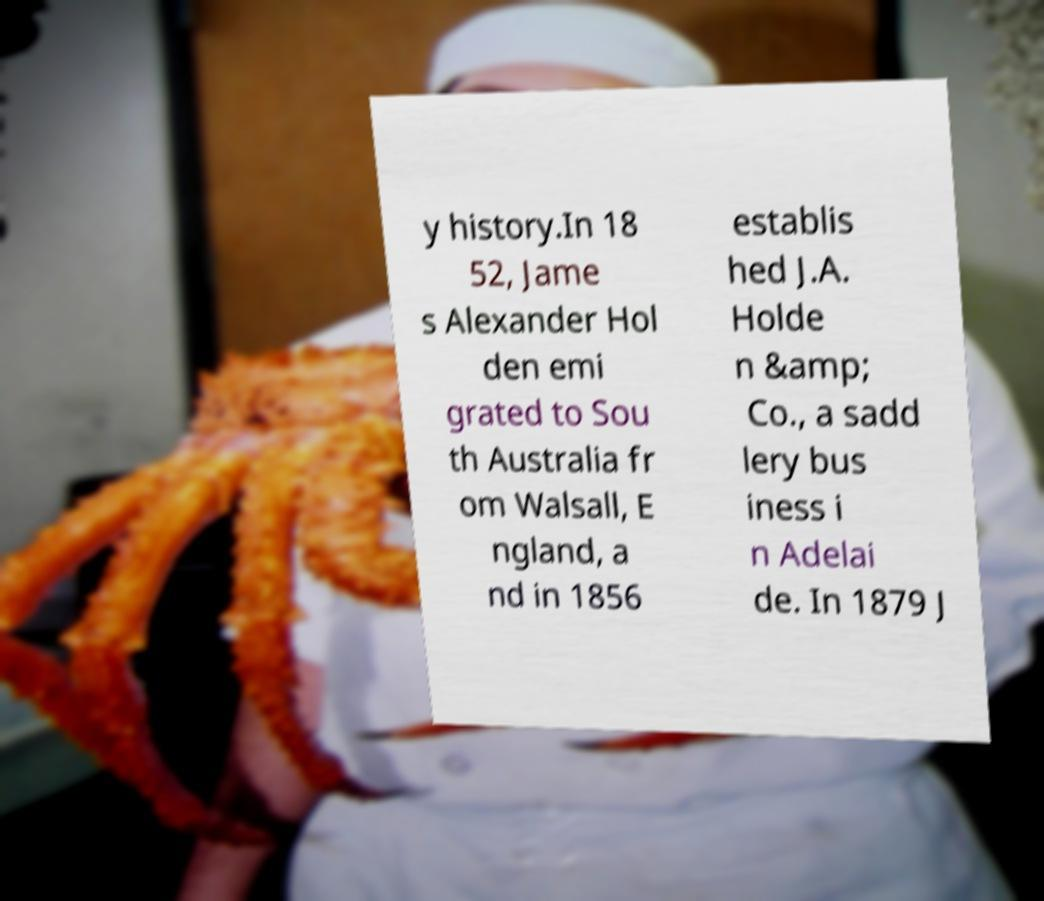Could you assist in decoding the text presented in this image and type it out clearly? y history.In 18 52, Jame s Alexander Hol den emi grated to Sou th Australia fr om Walsall, E ngland, a nd in 1856 establis hed J.A. Holde n &amp; Co., a sadd lery bus iness i n Adelai de. In 1879 J 